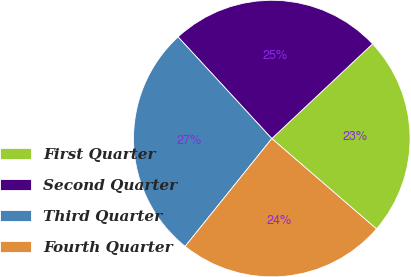Convert chart to OTSL. <chart><loc_0><loc_0><loc_500><loc_500><pie_chart><fcel>First Quarter<fcel>Second Quarter<fcel>Third Quarter<fcel>Fourth Quarter<nl><fcel>23.34%<fcel>24.85%<fcel>27.37%<fcel>24.44%<nl></chart> 